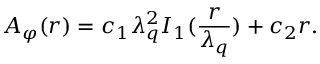<formula> <loc_0><loc_0><loc_500><loc_500>A _ { \varphi } ( r ) = c _ { 1 } \lambda _ { q } ^ { 2 } I _ { 1 } ( \frac { r } \lambda _ { q } } ) + c _ { 2 } r .</formula> 